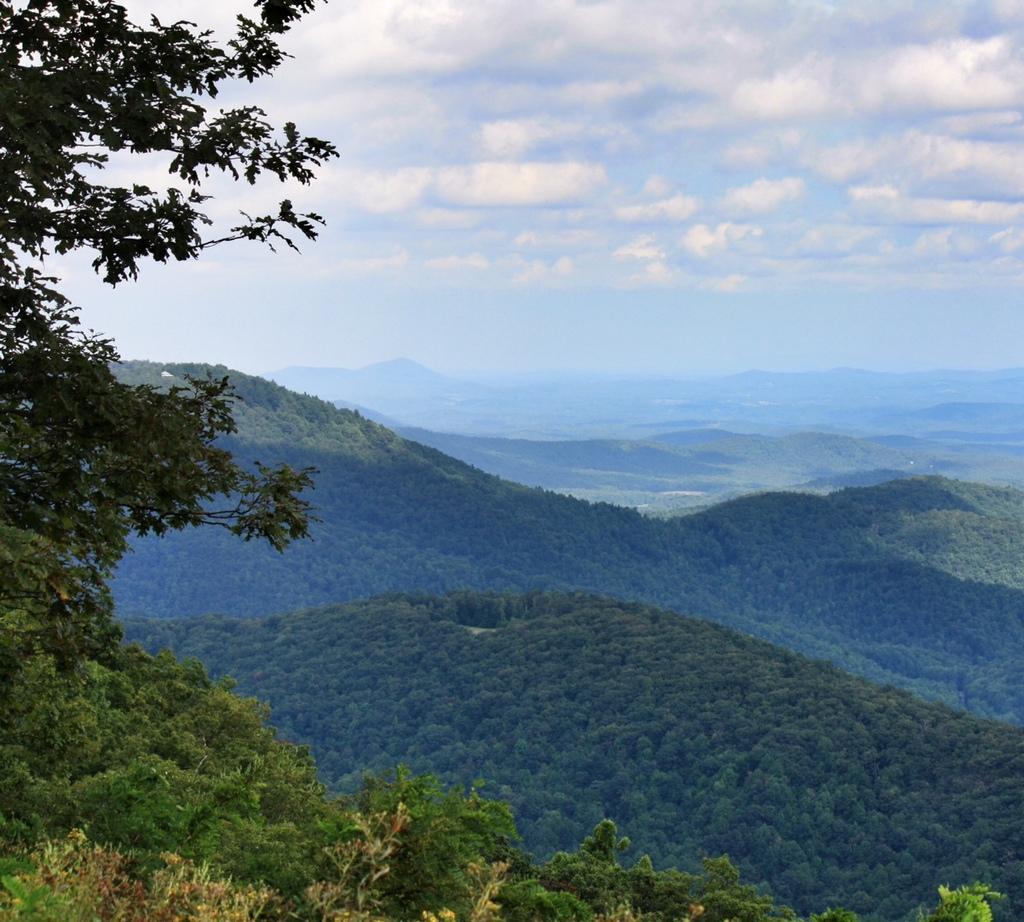Could you give a brief overview of what you see in this image? In this image I can see many trees. In the background I can see the mountains, clouds and the sky. 